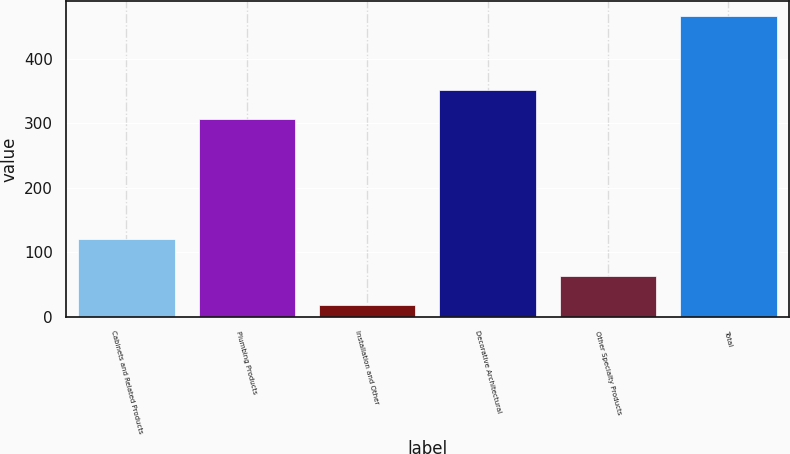Convert chart. <chart><loc_0><loc_0><loc_500><loc_500><bar_chart><fcel>Cabinets and Related Products<fcel>Plumbing Products<fcel>Installation and Other<fcel>Decorative Architectural<fcel>Other Specialty Products<fcel>Total<nl><fcel>120<fcel>307<fcel>19<fcel>351.7<fcel>63.7<fcel>466<nl></chart> 